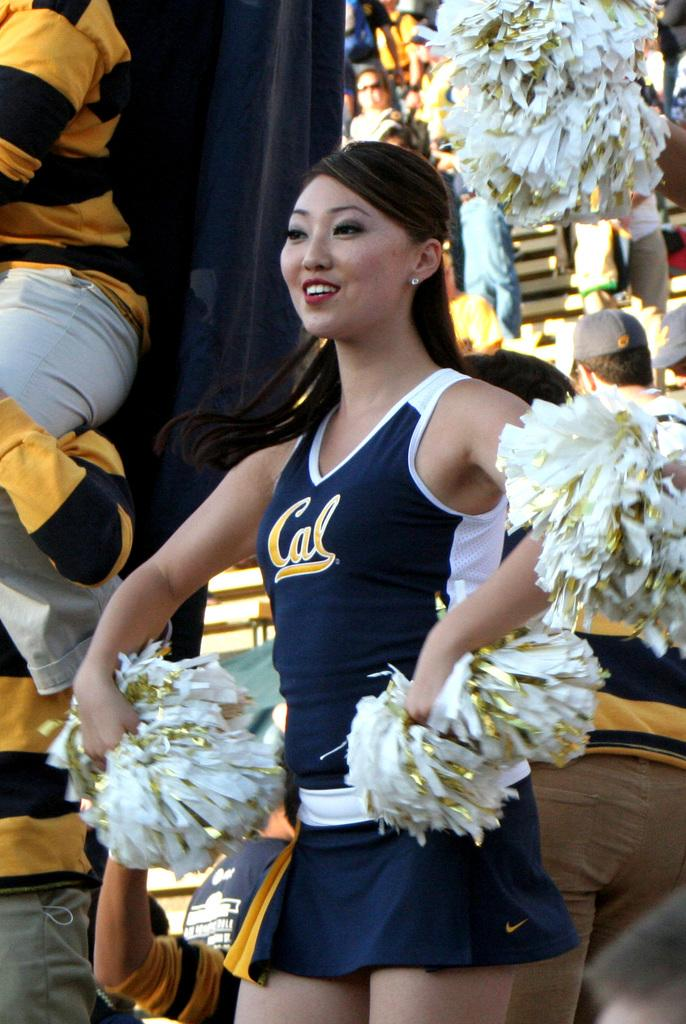Provide a one-sentence caption for the provided image. A cheerleader has the word Cal written on her vest. 